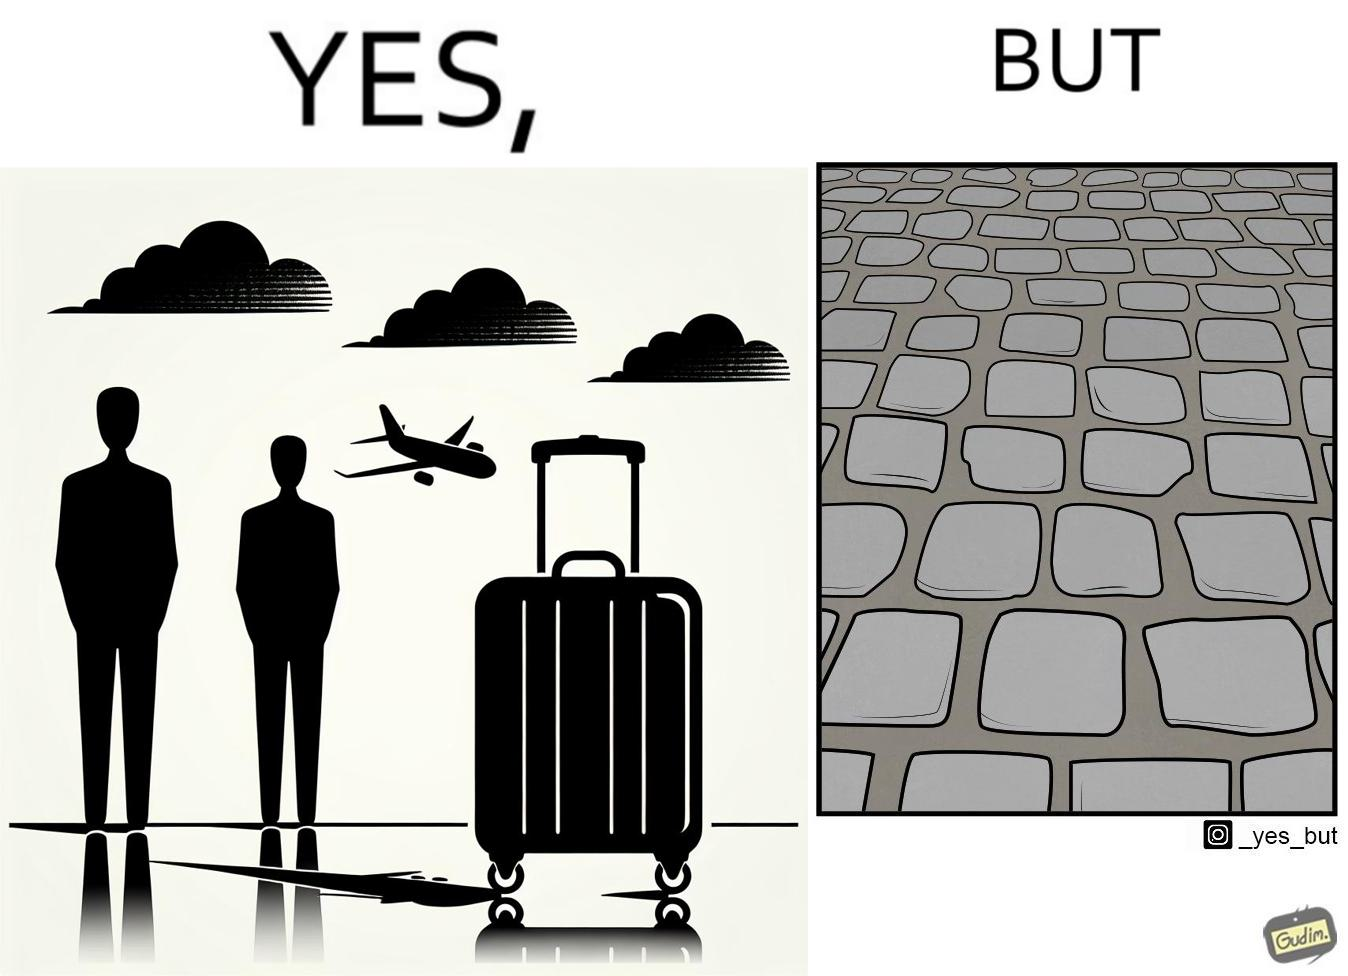What makes this image funny or satirical? The image is funny because even though the trolley bag is made to make carrying luggage easy, as soon as it encounters a rough surface like cobblestone road, it makes carrying luggage more difficult. 